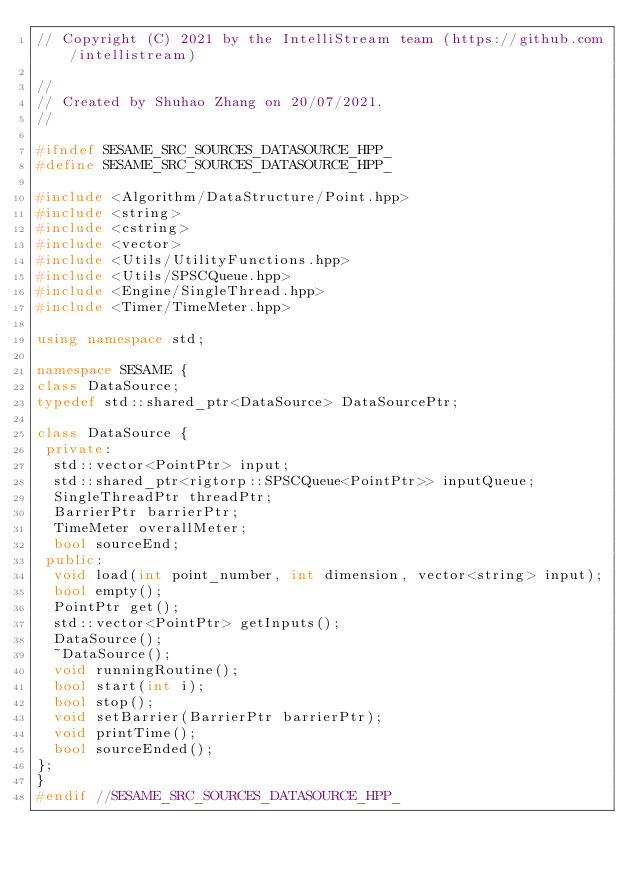Convert code to text. <code><loc_0><loc_0><loc_500><loc_500><_C++_>// Copyright (C) 2021 by the IntelliStream team (https://github.com/intellistream)

//
// Created by Shuhao Zhang on 20/07/2021.
//

#ifndef SESAME_SRC_SOURCES_DATASOURCE_HPP_
#define SESAME_SRC_SOURCES_DATASOURCE_HPP_

#include <Algorithm/DataStructure/Point.hpp>
#include <string>
#include <cstring>
#include <vector>
#include <Utils/UtilityFunctions.hpp>
#include <Utils/SPSCQueue.hpp>
#include <Engine/SingleThread.hpp>
#include <Timer/TimeMeter.hpp>

using namespace std;

namespace SESAME {
class DataSource;
typedef std::shared_ptr<DataSource> DataSourcePtr;

class DataSource {
 private:
  std::vector<PointPtr> input;
  std::shared_ptr<rigtorp::SPSCQueue<PointPtr>> inputQueue;
  SingleThreadPtr threadPtr;
  BarrierPtr barrierPtr;
  TimeMeter overallMeter;
  bool sourceEnd;
 public:
  void load(int point_number, int dimension, vector<string> input);
  bool empty();
  PointPtr get();
  std::vector<PointPtr> getInputs();
  DataSource();
  ~DataSource();
  void runningRoutine();
  bool start(int i);
  bool stop();
  void setBarrier(BarrierPtr barrierPtr);
  void printTime();
  bool sourceEnded();
};
}
#endif //SESAME_SRC_SOURCES_DATASOURCE_HPP_
</code> 